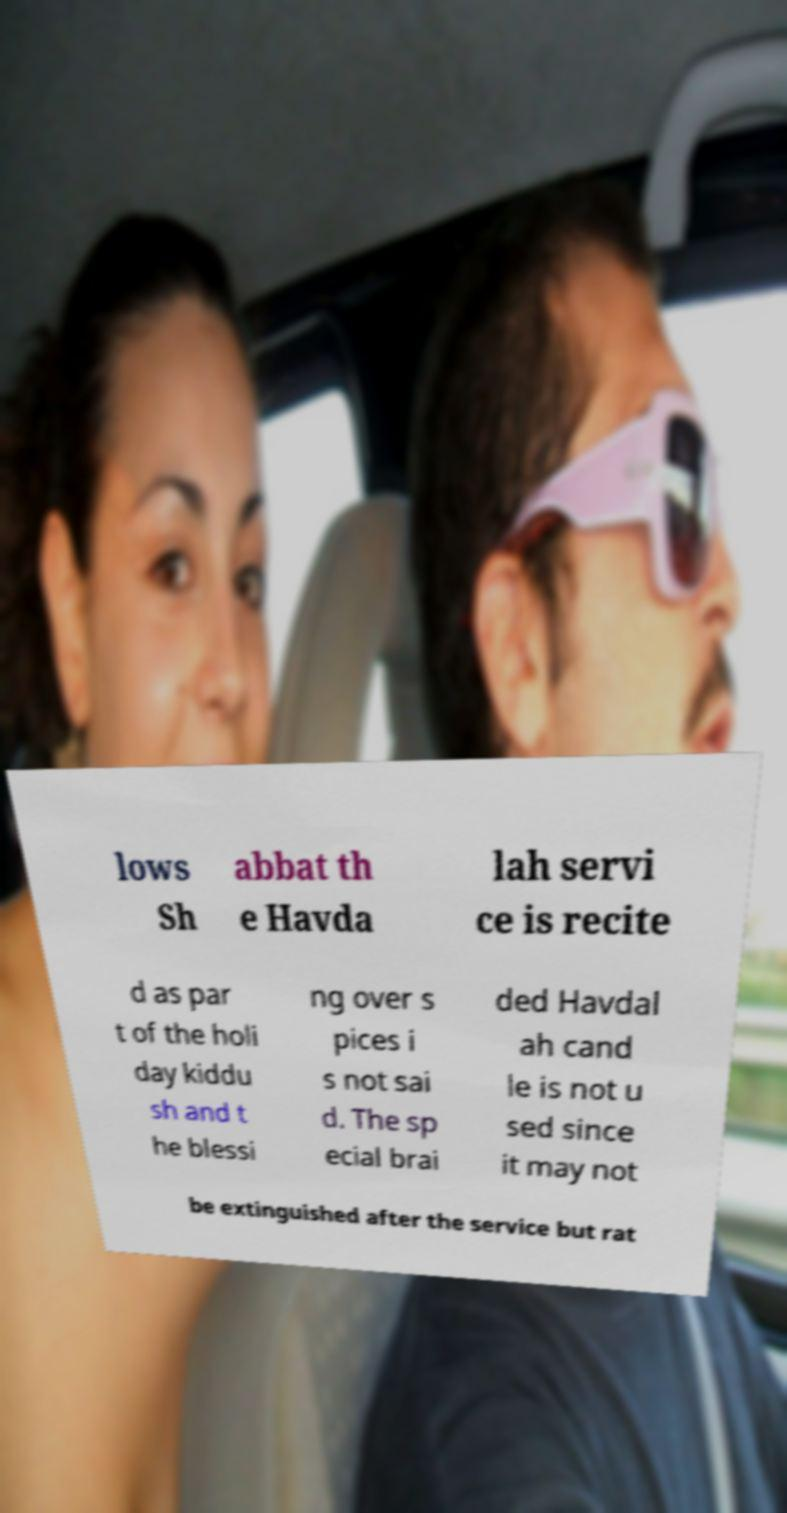Please identify and transcribe the text found in this image. lows Sh abbat th e Havda lah servi ce is recite d as par t of the holi day kiddu sh and t he blessi ng over s pices i s not sai d. The sp ecial brai ded Havdal ah cand le is not u sed since it may not be extinguished after the service but rat 